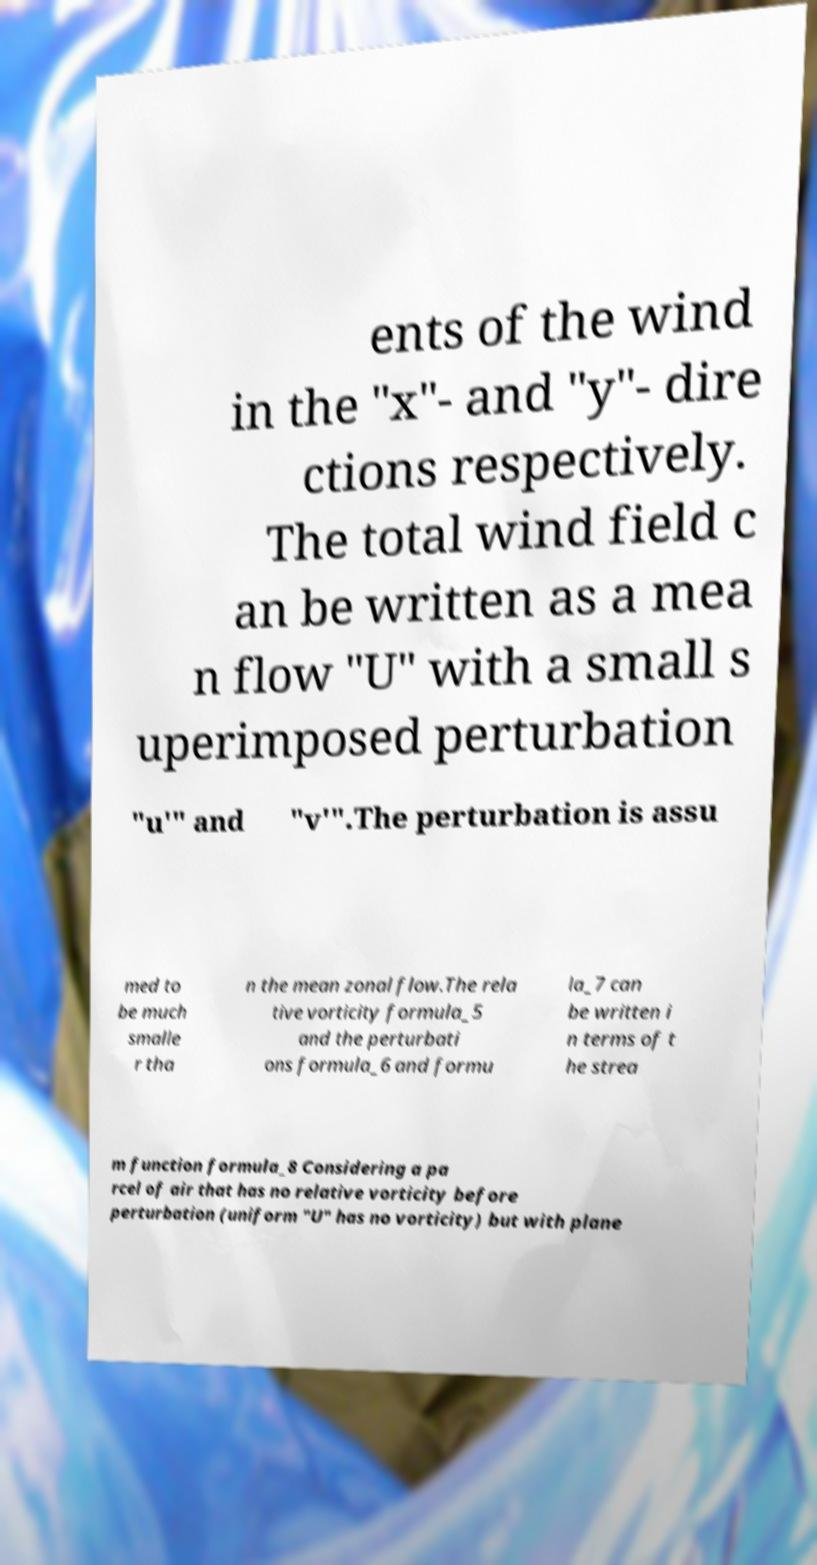What messages or text are displayed in this image? I need them in a readable, typed format. ents of the wind in the "x"- and "y"- dire ctions respectively. The total wind field c an be written as a mea n flow "U" with a small s uperimposed perturbation "u′" and "v′".The perturbation is assu med to be much smalle r tha n the mean zonal flow.The rela tive vorticity formula_5 and the perturbati ons formula_6 and formu la_7 can be written i n terms of t he strea m function formula_8 Considering a pa rcel of air that has no relative vorticity before perturbation (uniform "U" has no vorticity) but with plane 